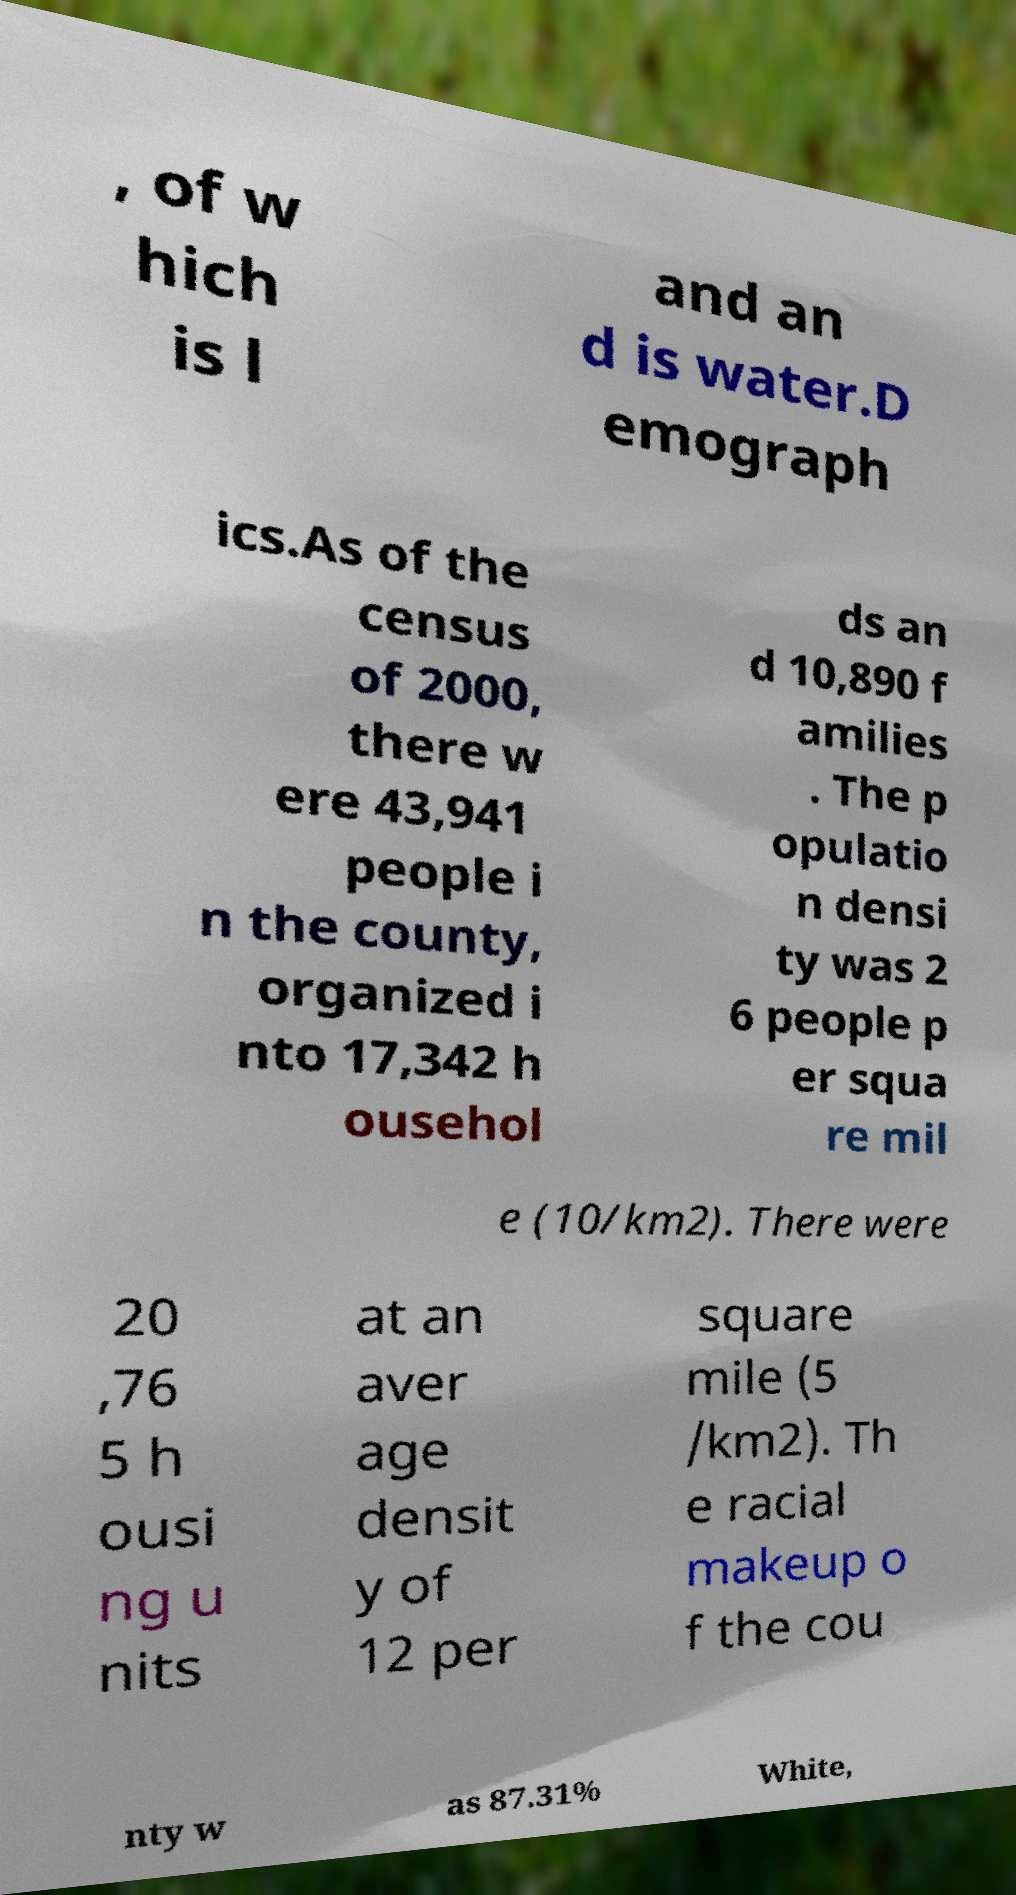Could you assist in decoding the text presented in this image and type it out clearly? , of w hich is l and an d is water.D emograph ics.As of the census of 2000, there w ere 43,941 people i n the county, organized i nto 17,342 h ousehol ds an d 10,890 f amilies . The p opulatio n densi ty was 2 6 people p er squa re mil e (10/km2). There were 20 ,76 5 h ousi ng u nits at an aver age densit y of 12 per square mile (5 /km2). Th e racial makeup o f the cou nty w as 87.31% White, 